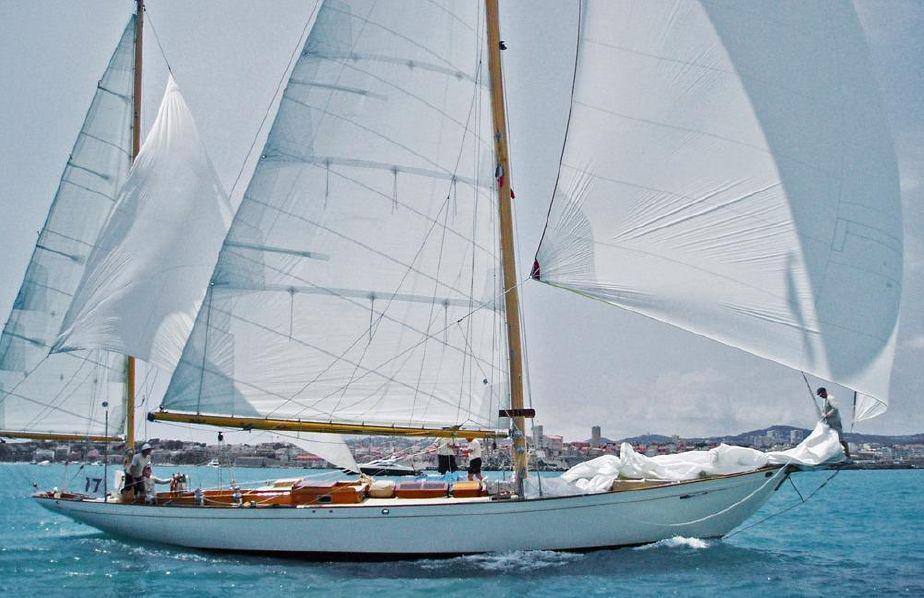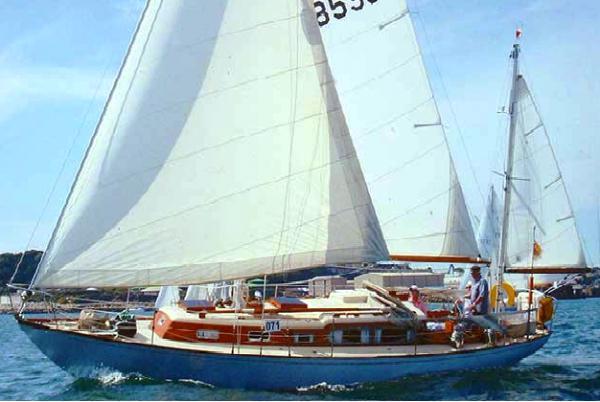The first image is the image on the left, the second image is the image on the right. For the images shown, is this caption "there are white inflated sails in the image on the right" true? Answer yes or no. Yes. The first image is the image on the left, the second image is the image on the right. Examine the images to the left and right. Is the description "At least one sailboat has white sails unfurled." accurate? Answer yes or no. Yes. 